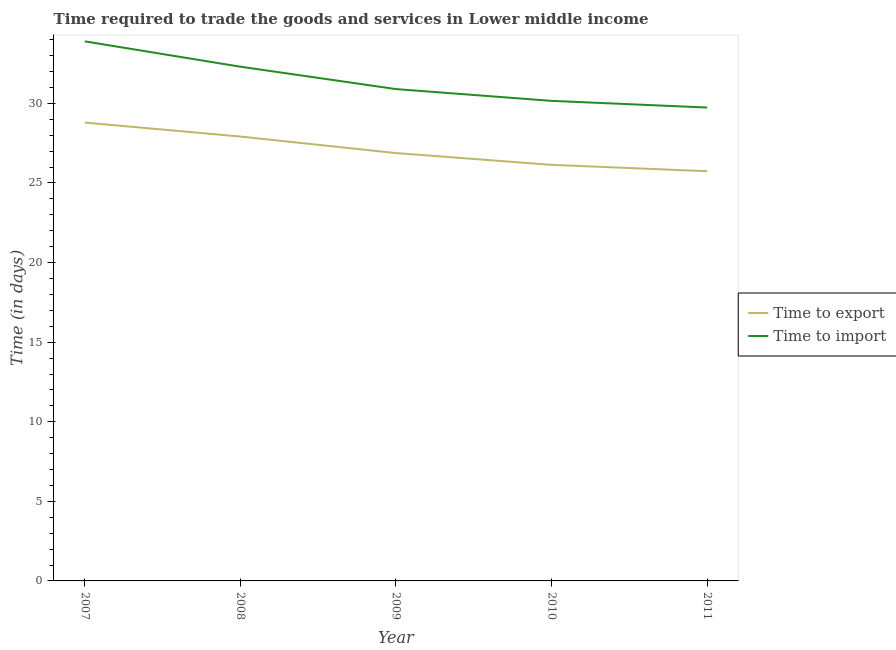Does the line corresponding to time to export intersect with the line corresponding to time to import?
Make the answer very short. No. Is the number of lines equal to the number of legend labels?
Keep it short and to the point. Yes. What is the time to export in 2010?
Offer a terse response. 26.14. Across all years, what is the maximum time to import?
Make the answer very short. 33.9. Across all years, what is the minimum time to import?
Your answer should be compact. 29.74. What is the total time to import in the graph?
Your answer should be very brief. 157. What is the difference between the time to import in 2009 and that in 2010?
Provide a short and direct response. 0.74. What is the difference between the time to import in 2010 and the time to export in 2008?
Ensure brevity in your answer.  2.24. What is the average time to export per year?
Ensure brevity in your answer.  27.09. In the year 2009, what is the difference between the time to import and time to export?
Provide a succinct answer. 4.02. In how many years, is the time to import greater than 33 days?
Offer a terse response. 1. What is the ratio of the time to export in 2007 to that in 2010?
Your answer should be very brief. 1.1. Is the difference between the time to import in 2007 and 2009 greater than the difference between the time to export in 2007 and 2009?
Provide a succinct answer. Yes. What is the difference between the highest and the second highest time to import?
Your response must be concise. 1.59. What is the difference between the highest and the lowest time to import?
Your answer should be very brief. 4.16. Does the time to import monotonically increase over the years?
Provide a short and direct response. No. How many lines are there?
Your answer should be compact. 2. Does the graph contain grids?
Your answer should be compact. No. How many legend labels are there?
Your response must be concise. 2. What is the title of the graph?
Your answer should be compact. Time required to trade the goods and services in Lower middle income. Does "From human activities" appear as one of the legend labels in the graph?
Your answer should be compact. No. What is the label or title of the Y-axis?
Provide a succinct answer. Time (in days). What is the Time (in days) of Time to export in 2007?
Your answer should be compact. 28.8. What is the Time (in days) of Time to import in 2007?
Make the answer very short. 33.9. What is the Time (in days) in Time to export in 2008?
Your answer should be very brief. 27.92. What is the Time (in days) of Time to import in 2008?
Your answer should be very brief. 32.31. What is the Time (in days) of Time to export in 2009?
Your answer should be compact. 26.88. What is the Time (in days) of Time to import in 2009?
Offer a very short reply. 30.9. What is the Time (in days) of Time to export in 2010?
Offer a very short reply. 26.14. What is the Time (in days) in Time to import in 2010?
Make the answer very short. 30.16. What is the Time (in days) in Time to export in 2011?
Provide a succinct answer. 25.74. What is the Time (in days) in Time to import in 2011?
Keep it short and to the point. 29.74. Across all years, what is the maximum Time (in days) of Time to export?
Your response must be concise. 28.8. Across all years, what is the maximum Time (in days) of Time to import?
Your answer should be compact. 33.9. Across all years, what is the minimum Time (in days) of Time to export?
Ensure brevity in your answer.  25.74. Across all years, what is the minimum Time (in days) of Time to import?
Your response must be concise. 29.74. What is the total Time (in days) in Time to export in the graph?
Offer a very short reply. 135.47. What is the total Time (in days) of Time to import in the graph?
Ensure brevity in your answer.  157. What is the difference between the Time (in days) in Time to export in 2007 and that in 2008?
Your response must be concise. 0.88. What is the difference between the Time (in days) in Time to import in 2007 and that in 2008?
Make the answer very short. 1.59. What is the difference between the Time (in days) of Time to export in 2007 and that in 2009?
Your response must be concise. 1.92. What is the difference between the Time (in days) of Time to import in 2007 and that in 2009?
Offer a terse response. 3. What is the difference between the Time (in days) in Time to export in 2007 and that in 2010?
Offer a terse response. 2.66. What is the difference between the Time (in days) of Time to import in 2007 and that in 2010?
Ensure brevity in your answer.  3.74. What is the difference between the Time (in days) in Time to export in 2007 and that in 2011?
Your answer should be compact. 3.06. What is the difference between the Time (in days) of Time to import in 2007 and that in 2011?
Your response must be concise. 4.16. What is the difference between the Time (in days) of Time to export in 2008 and that in 2009?
Ensure brevity in your answer.  1.04. What is the difference between the Time (in days) of Time to import in 2008 and that in 2009?
Ensure brevity in your answer.  1.41. What is the difference between the Time (in days) of Time to export in 2008 and that in 2010?
Your answer should be very brief. 1.78. What is the difference between the Time (in days) of Time to import in 2008 and that in 2010?
Your answer should be very brief. 2.15. What is the difference between the Time (in days) in Time to export in 2008 and that in 2011?
Your response must be concise. 2.18. What is the difference between the Time (in days) in Time to import in 2008 and that in 2011?
Make the answer very short. 2.57. What is the difference between the Time (in days) of Time to export in 2009 and that in 2010?
Keep it short and to the point. 0.74. What is the difference between the Time (in days) of Time to import in 2009 and that in 2010?
Offer a very short reply. 0.74. What is the difference between the Time (in days) of Time to export in 2009 and that in 2011?
Offer a terse response. 1.14. What is the difference between the Time (in days) of Time to import in 2009 and that in 2011?
Ensure brevity in your answer.  1.16. What is the difference between the Time (in days) of Time to export in 2010 and that in 2011?
Your answer should be compact. 0.4. What is the difference between the Time (in days) of Time to import in 2010 and that in 2011?
Give a very brief answer. 0.42. What is the difference between the Time (in days) of Time to export in 2007 and the Time (in days) of Time to import in 2008?
Your answer should be very brief. -3.51. What is the difference between the Time (in days) of Time to export in 2007 and the Time (in days) of Time to import in 2009?
Keep it short and to the point. -2.1. What is the difference between the Time (in days) in Time to export in 2007 and the Time (in days) in Time to import in 2010?
Your answer should be very brief. -1.36. What is the difference between the Time (in days) of Time to export in 2007 and the Time (in days) of Time to import in 2011?
Your response must be concise. -0.94. What is the difference between the Time (in days) in Time to export in 2008 and the Time (in days) in Time to import in 2009?
Your response must be concise. -2.98. What is the difference between the Time (in days) of Time to export in 2008 and the Time (in days) of Time to import in 2010?
Offer a very short reply. -2.24. What is the difference between the Time (in days) in Time to export in 2008 and the Time (in days) in Time to import in 2011?
Offer a very short reply. -1.82. What is the difference between the Time (in days) in Time to export in 2009 and the Time (in days) in Time to import in 2010?
Your response must be concise. -3.28. What is the difference between the Time (in days) in Time to export in 2009 and the Time (in days) in Time to import in 2011?
Offer a very short reply. -2.86. What is the difference between the Time (in days) of Time to export in 2010 and the Time (in days) of Time to import in 2011?
Provide a short and direct response. -3.6. What is the average Time (in days) of Time to export per year?
Give a very brief answer. 27.09. What is the average Time (in days) in Time to import per year?
Keep it short and to the point. 31.4. In the year 2007, what is the difference between the Time (in days) in Time to export and Time (in days) in Time to import?
Offer a terse response. -5.1. In the year 2008, what is the difference between the Time (in days) in Time to export and Time (in days) in Time to import?
Provide a short and direct response. -4.39. In the year 2009, what is the difference between the Time (in days) of Time to export and Time (in days) of Time to import?
Give a very brief answer. -4.02. In the year 2010, what is the difference between the Time (in days) of Time to export and Time (in days) of Time to import?
Make the answer very short. -4.02. In the year 2011, what is the difference between the Time (in days) of Time to export and Time (in days) of Time to import?
Your answer should be very brief. -4. What is the ratio of the Time (in days) in Time to export in 2007 to that in 2008?
Your answer should be very brief. 1.03. What is the ratio of the Time (in days) in Time to import in 2007 to that in 2008?
Make the answer very short. 1.05. What is the ratio of the Time (in days) in Time to export in 2007 to that in 2009?
Provide a short and direct response. 1.07. What is the ratio of the Time (in days) in Time to import in 2007 to that in 2009?
Your answer should be very brief. 1.1. What is the ratio of the Time (in days) of Time to export in 2007 to that in 2010?
Your answer should be compact. 1.1. What is the ratio of the Time (in days) in Time to import in 2007 to that in 2010?
Your response must be concise. 1.12. What is the ratio of the Time (in days) in Time to export in 2007 to that in 2011?
Provide a short and direct response. 1.12. What is the ratio of the Time (in days) in Time to import in 2007 to that in 2011?
Offer a very short reply. 1.14. What is the ratio of the Time (in days) of Time to export in 2008 to that in 2009?
Your answer should be compact. 1.04. What is the ratio of the Time (in days) in Time to import in 2008 to that in 2009?
Provide a short and direct response. 1.05. What is the ratio of the Time (in days) of Time to export in 2008 to that in 2010?
Your answer should be compact. 1.07. What is the ratio of the Time (in days) of Time to import in 2008 to that in 2010?
Keep it short and to the point. 1.07. What is the ratio of the Time (in days) in Time to export in 2008 to that in 2011?
Make the answer very short. 1.08. What is the ratio of the Time (in days) of Time to import in 2008 to that in 2011?
Keep it short and to the point. 1.09. What is the ratio of the Time (in days) of Time to export in 2009 to that in 2010?
Provide a short and direct response. 1.03. What is the ratio of the Time (in days) in Time to import in 2009 to that in 2010?
Your answer should be compact. 1.02. What is the ratio of the Time (in days) of Time to export in 2009 to that in 2011?
Ensure brevity in your answer.  1.04. What is the ratio of the Time (in days) of Time to import in 2009 to that in 2011?
Offer a terse response. 1.04. What is the ratio of the Time (in days) of Time to export in 2010 to that in 2011?
Offer a very short reply. 1.02. What is the ratio of the Time (in days) in Time to import in 2010 to that in 2011?
Provide a short and direct response. 1.01. What is the difference between the highest and the second highest Time (in days) in Time to export?
Ensure brevity in your answer.  0.88. What is the difference between the highest and the second highest Time (in days) of Time to import?
Provide a short and direct response. 1.59. What is the difference between the highest and the lowest Time (in days) of Time to export?
Your answer should be very brief. 3.06. What is the difference between the highest and the lowest Time (in days) of Time to import?
Offer a very short reply. 4.16. 